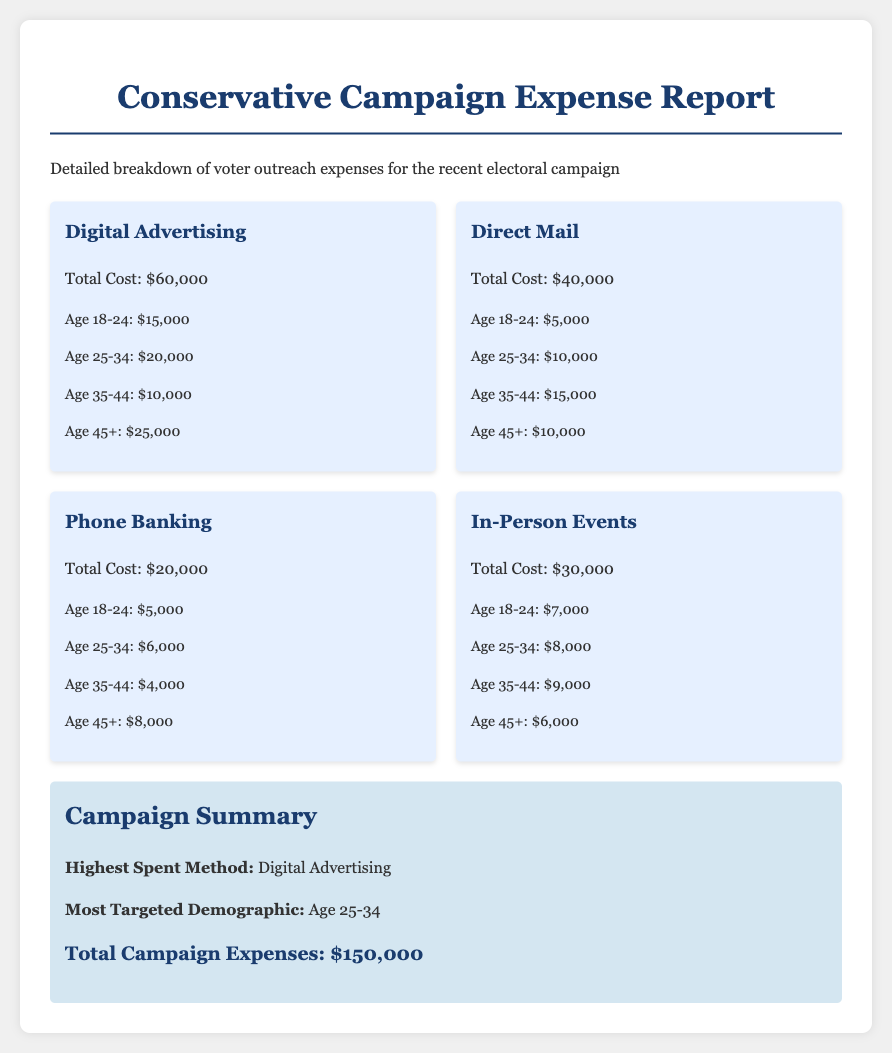What is the total cost of digital advertising? The total cost of digital advertising is specified in the document as $60,000.
Answer: $60,000 What is the most targeted demographic group? The document indicates that the most targeted demographic group is Age 25-34, which received the highest amount of outreach expenses.
Answer: Age 25-34 How much was spent on phone banking? The document clearly states that the total cost for phone banking is $20,000.
Answer: $20,000 Which method of communication had the highest expense? According to the document, the highest expense method is digital advertising, as it totals $60,000.
Answer: Digital Advertising What was the total campaign expense? The document summarizes the total campaign expenses as $150,000.
Answer: $150,000 How much was allocated for direct mail outreach to the Age 45+ demographic? The document breaks down direct mail expenses for the Age 45+ demographic as $10,000.
Answer: $10,000 What is the total cost for in-person events? The document specifies that the total cost for in-person events is $30,000.
Answer: $30,000 How much was spent on voter outreach for the Age 18-24 demographic in digital advertising? The document states that digital advertising for the Age 18-24 demographic cost $15,000.
Answer: $15,000 